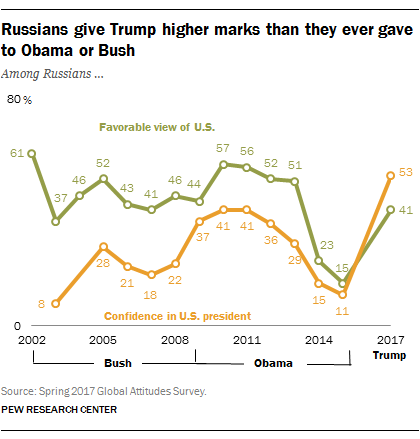Give some essential details in this illustration. The favourable view of the United States is currently 15%. The value of confidence in the US president, Donald Trump, is higher than the favorable view of the US. 